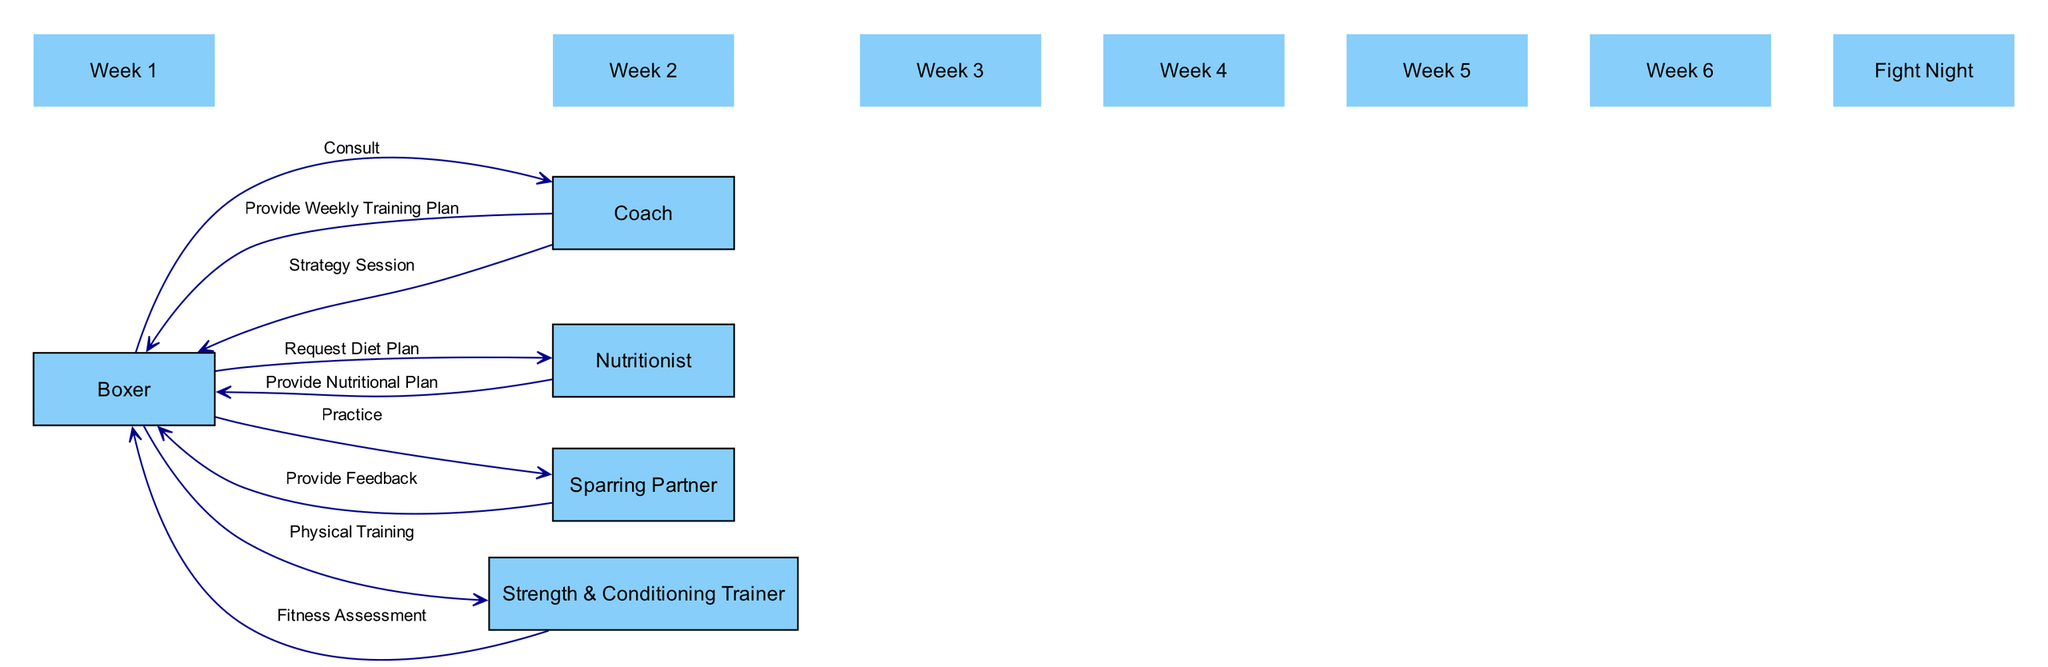What are the names of the main participants in the boxing preparation sequence? The diagram includes five main participants: Boxer, Coach, Nutritionist, Sparring Partner, and Strength & Conditioning Trainer. These are visible as nodes, representing the people involved in the preparation process.
Answer: Boxer, Coach, Nutritionist, Sparring Partner, Strength & Conditioning Trainer Who does the Boxer consult with to develop their training plan? The Boxer has a direct edge labeled "Consult" to the Coach, indicating that the Coach is the one the Boxer consults with to develop their training plan.
Answer: Coach How many edges are there in the diagram? By counting all the connections between the participants and actions, there are eight directed edges in total, showing the interactions during the preparation process.
Answer: Eight What is provided by the Nutritionist to the Boxer? The arrow directed from the Nutritionist to the Boxer is labeled "Provide Nutritional Plan," indicating that this is the output of the Nutritionist's actions in the diagram.
Answer: Nutritional Plan Which participant is responsible for practice and feedback? The diagram shows the Boxer practicing with the Sparring Partner, and the Sparring Partner provides feedback to the Boxer, making them responsible for both practice and feedback in the preparation process.
Answer: Sparring Partner In which week does Fight Night occur according to the timeline? The timeline in the diagram lists Fight Night as the last event, directly following the six weeks of training, making it clear that it is depicted as occurring after this preparation period.
Answer: Fight Night What is the main purpose of the Strategy Session between the Coach and the Boxer? The edge labeled "Strategy Session" emphasizes that this interaction is primarily for discussing tactics and game plans against the opponent, outlining its purpose clearly within the diagram's context.
Answer: Tactics and game plan How does the Strength & Conditioning Trainer assist the Boxer? The diagram includes edges indicating interactions where the Boxer engages in "Physical Training" and receives a "Fitness Assessment," highlighting the trainer's role in improving the Boxer's physical condition.
Answer: Fitness Assessment 